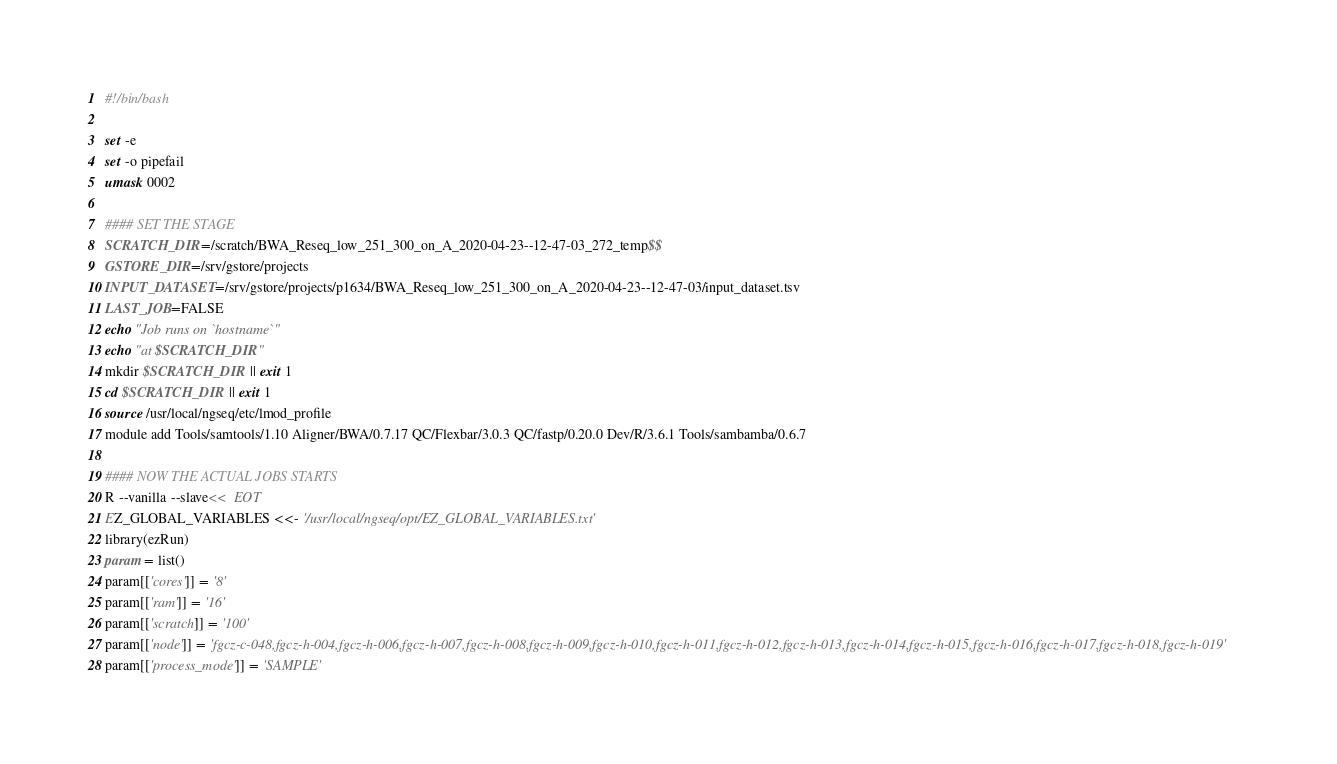<code> <loc_0><loc_0><loc_500><loc_500><_Bash_>#!/bin/bash

set -e
set -o pipefail
umask 0002

#### SET THE STAGE
SCRATCH_DIR=/scratch/BWA_Reseq_low_251_300_on_A_2020-04-23--12-47-03_272_temp$$
GSTORE_DIR=/srv/gstore/projects
INPUT_DATASET=/srv/gstore/projects/p1634/BWA_Reseq_low_251_300_on_A_2020-04-23--12-47-03/input_dataset.tsv
LAST_JOB=FALSE
echo "Job runs on `hostname`"
echo "at $SCRATCH_DIR"
mkdir $SCRATCH_DIR || exit 1
cd $SCRATCH_DIR || exit 1
source /usr/local/ngseq/etc/lmod_profile
module add Tools/samtools/1.10 Aligner/BWA/0.7.17 QC/Flexbar/3.0.3 QC/fastp/0.20.0 Dev/R/3.6.1 Tools/sambamba/0.6.7

#### NOW THE ACTUAL JOBS STARTS
R --vanilla --slave<<  EOT
EZ_GLOBAL_VARIABLES <<- '/usr/local/ngseq/opt/EZ_GLOBAL_VARIABLES.txt'
library(ezRun)
param = list()
param[['cores']] = '8'
param[['ram']] = '16'
param[['scratch']] = '100'
param[['node']] = 'fgcz-c-048,fgcz-h-004,fgcz-h-006,fgcz-h-007,fgcz-h-008,fgcz-h-009,fgcz-h-010,fgcz-h-011,fgcz-h-012,fgcz-h-013,fgcz-h-014,fgcz-h-015,fgcz-h-016,fgcz-h-017,fgcz-h-018,fgcz-h-019'
param[['process_mode']] = 'SAMPLE'</code> 